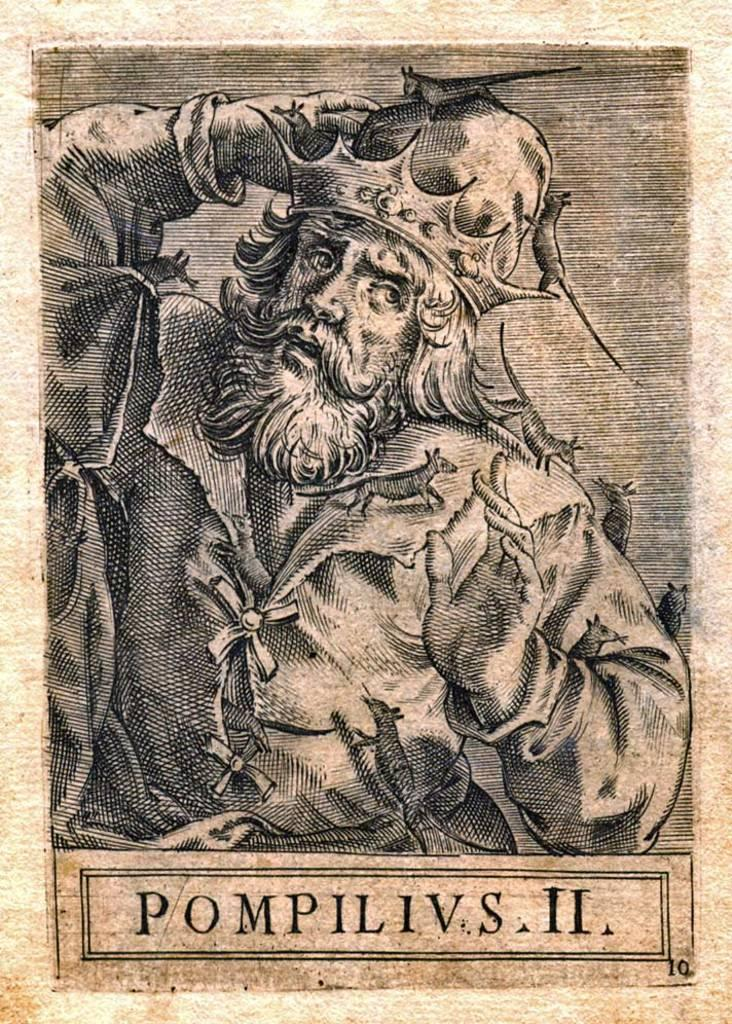<image>
Write a terse but informative summary of the picture. a page with a man drawn on it that reads: POMPILIVS II 